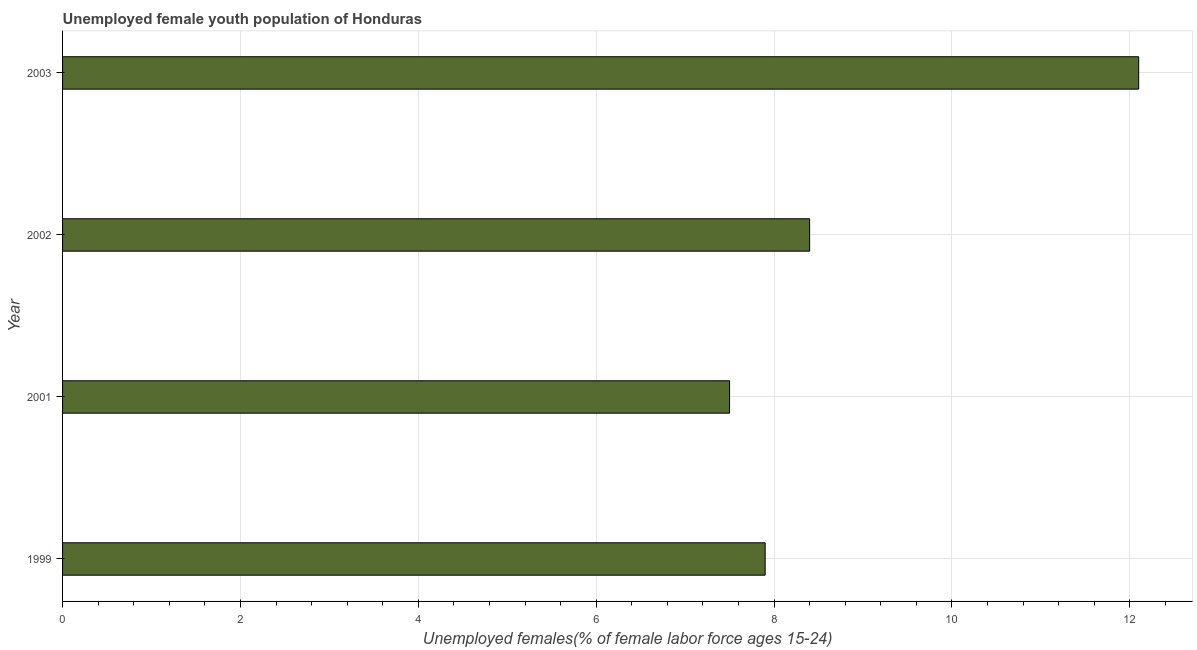Does the graph contain any zero values?
Ensure brevity in your answer.  No. What is the title of the graph?
Provide a short and direct response. Unemployed female youth population of Honduras. What is the label or title of the X-axis?
Ensure brevity in your answer.  Unemployed females(% of female labor force ages 15-24). What is the unemployed female youth in 1999?
Your answer should be compact. 7.9. Across all years, what is the maximum unemployed female youth?
Your answer should be very brief. 12.1. In which year was the unemployed female youth minimum?
Make the answer very short. 2001. What is the sum of the unemployed female youth?
Provide a short and direct response. 35.9. What is the average unemployed female youth per year?
Keep it short and to the point. 8.97. What is the median unemployed female youth?
Your response must be concise. 8.15. In how many years, is the unemployed female youth greater than 7.2 %?
Give a very brief answer. 4. Do a majority of the years between 1999 and 2001 (inclusive) have unemployed female youth greater than 4.4 %?
Keep it short and to the point. Yes. What is the ratio of the unemployed female youth in 2001 to that in 2002?
Give a very brief answer. 0.89. Is the unemployed female youth in 1999 less than that in 2003?
Give a very brief answer. Yes. How many bars are there?
Give a very brief answer. 4. How many years are there in the graph?
Your response must be concise. 4. What is the Unemployed females(% of female labor force ages 15-24) in 1999?
Your answer should be compact. 7.9. What is the Unemployed females(% of female labor force ages 15-24) in 2001?
Provide a succinct answer. 7.5. What is the Unemployed females(% of female labor force ages 15-24) in 2002?
Your answer should be very brief. 8.4. What is the Unemployed females(% of female labor force ages 15-24) of 2003?
Ensure brevity in your answer.  12.1. What is the difference between the Unemployed females(% of female labor force ages 15-24) in 2001 and 2002?
Your answer should be compact. -0.9. What is the ratio of the Unemployed females(% of female labor force ages 15-24) in 1999 to that in 2001?
Your answer should be compact. 1.05. What is the ratio of the Unemployed females(% of female labor force ages 15-24) in 1999 to that in 2002?
Offer a very short reply. 0.94. What is the ratio of the Unemployed females(% of female labor force ages 15-24) in 1999 to that in 2003?
Ensure brevity in your answer.  0.65. What is the ratio of the Unemployed females(% of female labor force ages 15-24) in 2001 to that in 2002?
Offer a very short reply. 0.89. What is the ratio of the Unemployed females(% of female labor force ages 15-24) in 2001 to that in 2003?
Give a very brief answer. 0.62. What is the ratio of the Unemployed females(% of female labor force ages 15-24) in 2002 to that in 2003?
Provide a succinct answer. 0.69. 